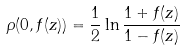<formula> <loc_0><loc_0><loc_500><loc_500>\rho ( 0 , f ( z ) ) = \frac { 1 } { 2 } \ln \frac { 1 + f ( z ) } { 1 - f ( z ) }</formula> 